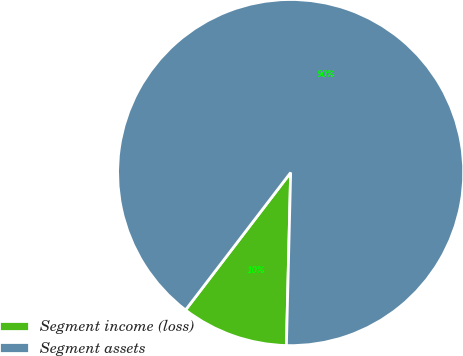<chart> <loc_0><loc_0><loc_500><loc_500><pie_chart><fcel>Segment income (loss)<fcel>Segment assets<nl><fcel>10.0%<fcel>90.0%<nl></chart> 